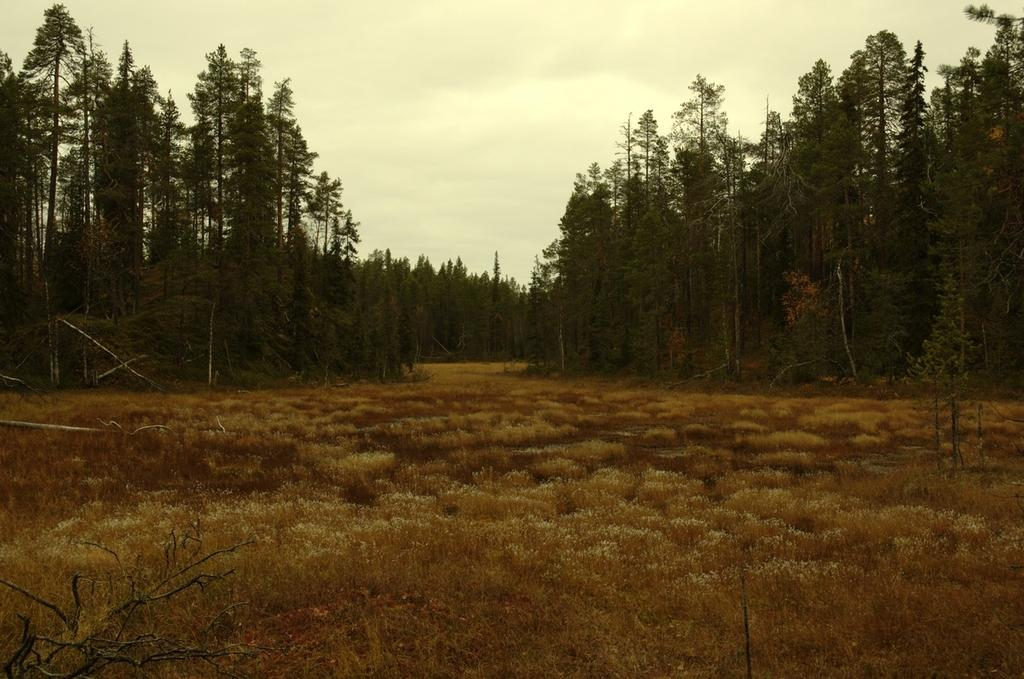What type of vegetation is present at the bottom of the image? There are plants and grass on the ground at the bottom of the image. What can be seen in the background of the image? There are trees, plants, and grass on the ground in the background. What is visible in the sky in the image? There are clouds visible in the sky. What type of lipstick is being used by the tree in the image? There are no people or objects in the image that would use lipstick, and trees do not use lipstick. Can you locate the map in the image? There is no map present in the image. 